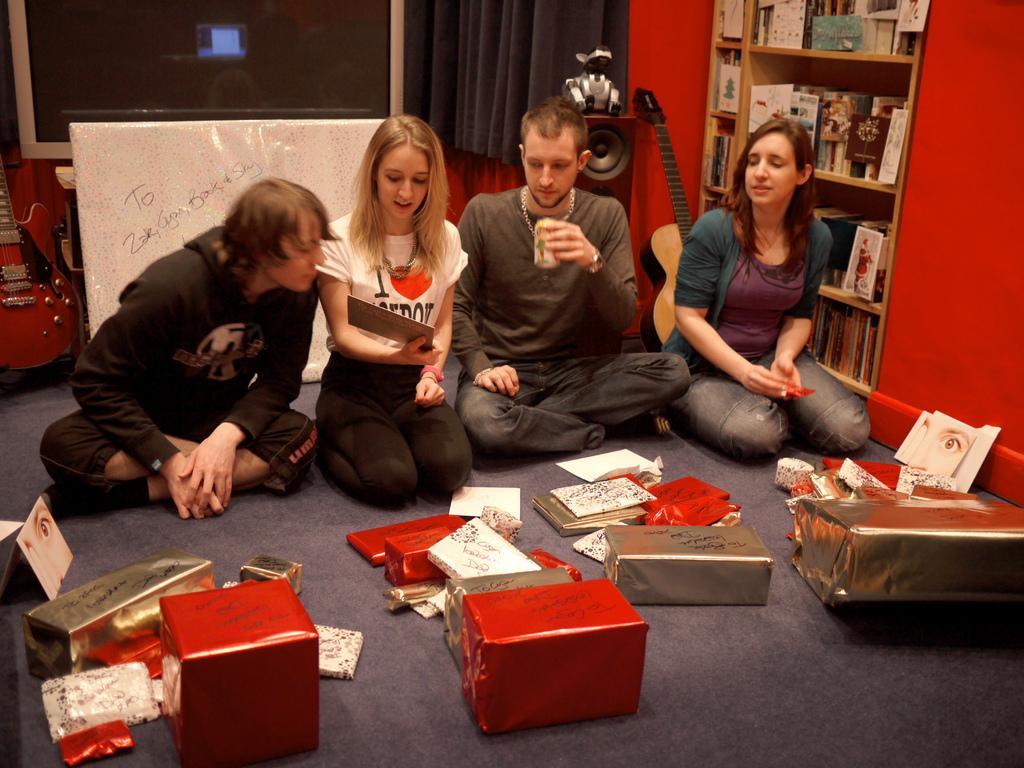In one or two sentences, can you explain what this image depicts? In this picture there are people those who are sitting in the center of the image, on the floor and there are gifts in front of them, there is book shelf and a guitar on the right side of the image and there is a television and another guitar on the left side of the image. 